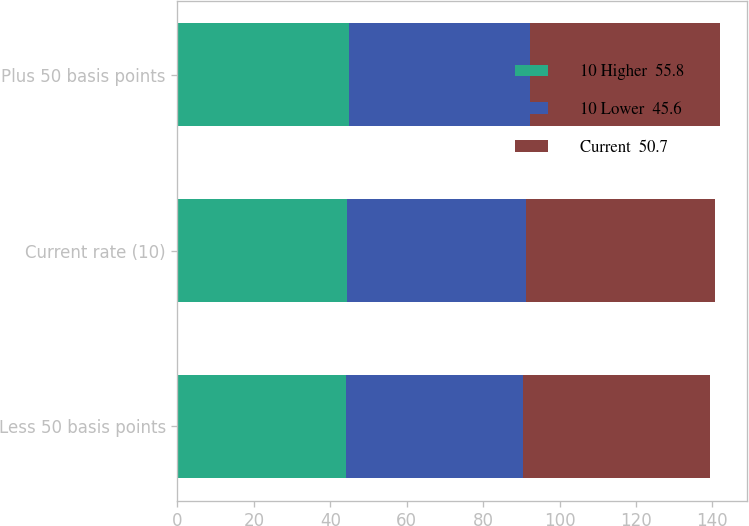Convert chart. <chart><loc_0><loc_0><loc_500><loc_500><stacked_bar_chart><ecel><fcel>Less 50 basis points<fcel>Current rate (10)<fcel>Plus 50 basis points<nl><fcel>10 Higher  55.8<fcel>44<fcel>44.4<fcel>44.9<nl><fcel>10 Lower  45.6<fcel>46.5<fcel>46.9<fcel>47.3<nl><fcel>Current  50.7<fcel>48.9<fcel>49.3<fcel>49.8<nl></chart> 